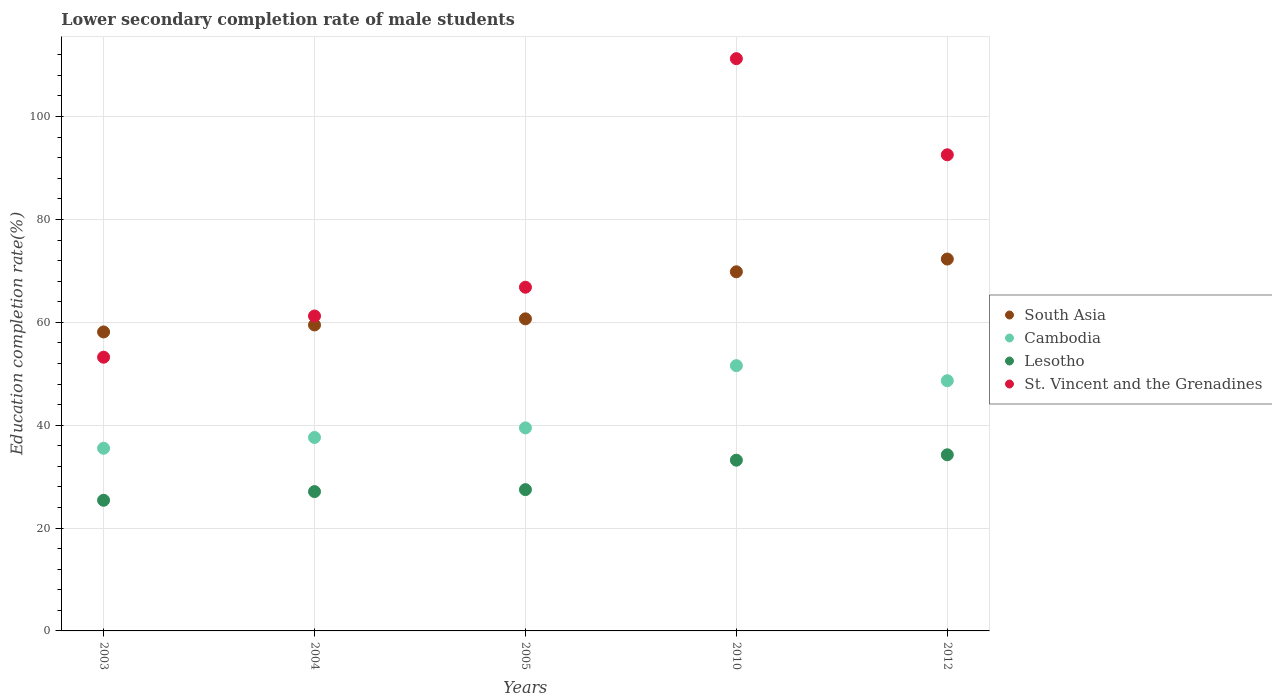How many different coloured dotlines are there?
Offer a terse response. 4. Is the number of dotlines equal to the number of legend labels?
Keep it short and to the point. Yes. What is the lower secondary completion rate of male students in Lesotho in 2012?
Your answer should be very brief. 34.24. Across all years, what is the maximum lower secondary completion rate of male students in St. Vincent and the Grenadines?
Keep it short and to the point. 111.26. Across all years, what is the minimum lower secondary completion rate of male students in Lesotho?
Offer a very short reply. 25.4. In which year was the lower secondary completion rate of male students in South Asia maximum?
Give a very brief answer. 2012. In which year was the lower secondary completion rate of male students in South Asia minimum?
Your answer should be very brief. 2003. What is the total lower secondary completion rate of male students in St. Vincent and the Grenadines in the graph?
Your answer should be very brief. 385.08. What is the difference between the lower secondary completion rate of male students in St. Vincent and the Grenadines in 2004 and that in 2012?
Offer a terse response. -31.34. What is the difference between the lower secondary completion rate of male students in Cambodia in 2005 and the lower secondary completion rate of male students in South Asia in 2012?
Keep it short and to the point. -32.83. What is the average lower secondary completion rate of male students in Cambodia per year?
Your answer should be very brief. 42.56. In the year 2003, what is the difference between the lower secondary completion rate of male students in South Asia and lower secondary completion rate of male students in Lesotho?
Offer a very short reply. 32.73. In how many years, is the lower secondary completion rate of male students in Lesotho greater than 108 %?
Keep it short and to the point. 0. What is the ratio of the lower secondary completion rate of male students in Cambodia in 2003 to that in 2010?
Your answer should be very brief. 0.69. Is the lower secondary completion rate of male students in St. Vincent and the Grenadines in 2010 less than that in 2012?
Provide a succinct answer. No. Is the difference between the lower secondary completion rate of male students in South Asia in 2004 and 2010 greater than the difference between the lower secondary completion rate of male students in Lesotho in 2004 and 2010?
Provide a short and direct response. No. What is the difference between the highest and the second highest lower secondary completion rate of male students in South Asia?
Give a very brief answer. 2.47. What is the difference between the highest and the lowest lower secondary completion rate of male students in Lesotho?
Provide a short and direct response. 8.84. In how many years, is the lower secondary completion rate of male students in St. Vincent and the Grenadines greater than the average lower secondary completion rate of male students in St. Vincent and the Grenadines taken over all years?
Your answer should be compact. 2. Is the sum of the lower secondary completion rate of male students in Lesotho in 2004 and 2005 greater than the maximum lower secondary completion rate of male students in St. Vincent and the Grenadines across all years?
Make the answer very short. No. Is it the case that in every year, the sum of the lower secondary completion rate of male students in South Asia and lower secondary completion rate of male students in St. Vincent and the Grenadines  is greater than the sum of lower secondary completion rate of male students in Cambodia and lower secondary completion rate of male students in Lesotho?
Offer a very short reply. Yes. Is it the case that in every year, the sum of the lower secondary completion rate of male students in Cambodia and lower secondary completion rate of male students in St. Vincent and the Grenadines  is greater than the lower secondary completion rate of male students in South Asia?
Make the answer very short. Yes. Is the lower secondary completion rate of male students in Lesotho strictly greater than the lower secondary completion rate of male students in South Asia over the years?
Give a very brief answer. No. Is the lower secondary completion rate of male students in Cambodia strictly less than the lower secondary completion rate of male students in Lesotho over the years?
Offer a very short reply. No. How many dotlines are there?
Your answer should be very brief. 4. Are the values on the major ticks of Y-axis written in scientific E-notation?
Offer a very short reply. No. Does the graph contain any zero values?
Give a very brief answer. No. What is the title of the graph?
Give a very brief answer. Lower secondary completion rate of male students. Does "Finland" appear as one of the legend labels in the graph?
Your answer should be very brief. No. What is the label or title of the Y-axis?
Offer a terse response. Education completion rate(%). What is the Education completion rate(%) in South Asia in 2003?
Offer a terse response. 58.12. What is the Education completion rate(%) in Cambodia in 2003?
Offer a terse response. 35.51. What is the Education completion rate(%) of Lesotho in 2003?
Keep it short and to the point. 25.4. What is the Education completion rate(%) of St. Vincent and the Grenadines in 2003?
Provide a succinct answer. 53.21. What is the Education completion rate(%) of South Asia in 2004?
Make the answer very short. 59.48. What is the Education completion rate(%) in Cambodia in 2004?
Offer a terse response. 37.61. What is the Education completion rate(%) in Lesotho in 2004?
Offer a very short reply. 27.09. What is the Education completion rate(%) of St. Vincent and the Grenadines in 2004?
Give a very brief answer. 61.23. What is the Education completion rate(%) of South Asia in 2005?
Make the answer very short. 60.67. What is the Education completion rate(%) in Cambodia in 2005?
Provide a short and direct response. 39.47. What is the Education completion rate(%) in Lesotho in 2005?
Your answer should be very brief. 27.47. What is the Education completion rate(%) of St. Vincent and the Grenadines in 2005?
Your answer should be compact. 66.82. What is the Education completion rate(%) in South Asia in 2010?
Make the answer very short. 69.82. What is the Education completion rate(%) of Cambodia in 2010?
Ensure brevity in your answer.  51.57. What is the Education completion rate(%) in Lesotho in 2010?
Your response must be concise. 33.19. What is the Education completion rate(%) of St. Vincent and the Grenadines in 2010?
Your answer should be very brief. 111.26. What is the Education completion rate(%) in South Asia in 2012?
Make the answer very short. 72.3. What is the Education completion rate(%) in Cambodia in 2012?
Provide a short and direct response. 48.64. What is the Education completion rate(%) in Lesotho in 2012?
Your answer should be very brief. 34.24. What is the Education completion rate(%) in St. Vincent and the Grenadines in 2012?
Your answer should be very brief. 92.56. Across all years, what is the maximum Education completion rate(%) in South Asia?
Ensure brevity in your answer.  72.3. Across all years, what is the maximum Education completion rate(%) in Cambodia?
Your answer should be compact. 51.57. Across all years, what is the maximum Education completion rate(%) in Lesotho?
Provide a succinct answer. 34.24. Across all years, what is the maximum Education completion rate(%) of St. Vincent and the Grenadines?
Make the answer very short. 111.26. Across all years, what is the minimum Education completion rate(%) of South Asia?
Keep it short and to the point. 58.12. Across all years, what is the minimum Education completion rate(%) in Cambodia?
Provide a short and direct response. 35.51. Across all years, what is the minimum Education completion rate(%) in Lesotho?
Offer a terse response. 25.4. Across all years, what is the minimum Education completion rate(%) of St. Vincent and the Grenadines?
Your answer should be compact. 53.21. What is the total Education completion rate(%) in South Asia in the graph?
Provide a succinct answer. 320.39. What is the total Education completion rate(%) of Cambodia in the graph?
Your answer should be very brief. 212.8. What is the total Education completion rate(%) of Lesotho in the graph?
Make the answer very short. 147.39. What is the total Education completion rate(%) of St. Vincent and the Grenadines in the graph?
Offer a very short reply. 385.08. What is the difference between the Education completion rate(%) in South Asia in 2003 and that in 2004?
Ensure brevity in your answer.  -1.36. What is the difference between the Education completion rate(%) of Cambodia in 2003 and that in 2004?
Your answer should be compact. -2.1. What is the difference between the Education completion rate(%) of Lesotho in 2003 and that in 2004?
Give a very brief answer. -1.69. What is the difference between the Education completion rate(%) of St. Vincent and the Grenadines in 2003 and that in 2004?
Your answer should be very brief. -8.01. What is the difference between the Education completion rate(%) in South Asia in 2003 and that in 2005?
Keep it short and to the point. -2.55. What is the difference between the Education completion rate(%) of Cambodia in 2003 and that in 2005?
Give a very brief answer. -3.96. What is the difference between the Education completion rate(%) of Lesotho in 2003 and that in 2005?
Your response must be concise. -2.07. What is the difference between the Education completion rate(%) in St. Vincent and the Grenadines in 2003 and that in 2005?
Keep it short and to the point. -13.6. What is the difference between the Education completion rate(%) in South Asia in 2003 and that in 2010?
Your answer should be compact. -11.7. What is the difference between the Education completion rate(%) in Cambodia in 2003 and that in 2010?
Your answer should be very brief. -16.06. What is the difference between the Education completion rate(%) of Lesotho in 2003 and that in 2010?
Offer a terse response. -7.8. What is the difference between the Education completion rate(%) in St. Vincent and the Grenadines in 2003 and that in 2010?
Offer a very short reply. -58.04. What is the difference between the Education completion rate(%) in South Asia in 2003 and that in 2012?
Provide a succinct answer. -14.17. What is the difference between the Education completion rate(%) in Cambodia in 2003 and that in 2012?
Offer a terse response. -13.13. What is the difference between the Education completion rate(%) of Lesotho in 2003 and that in 2012?
Your response must be concise. -8.84. What is the difference between the Education completion rate(%) in St. Vincent and the Grenadines in 2003 and that in 2012?
Make the answer very short. -39.35. What is the difference between the Education completion rate(%) of South Asia in 2004 and that in 2005?
Offer a very short reply. -1.19. What is the difference between the Education completion rate(%) in Cambodia in 2004 and that in 2005?
Give a very brief answer. -1.86. What is the difference between the Education completion rate(%) of Lesotho in 2004 and that in 2005?
Your response must be concise. -0.38. What is the difference between the Education completion rate(%) in St. Vincent and the Grenadines in 2004 and that in 2005?
Provide a short and direct response. -5.59. What is the difference between the Education completion rate(%) in South Asia in 2004 and that in 2010?
Offer a terse response. -10.34. What is the difference between the Education completion rate(%) in Cambodia in 2004 and that in 2010?
Provide a short and direct response. -13.97. What is the difference between the Education completion rate(%) of Lesotho in 2004 and that in 2010?
Make the answer very short. -6.11. What is the difference between the Education completion rate(%) of St. Vincent and the Grenadines in 2004 and that in 2010?
Ensure brevity in your answer.  -50.03. What is the difference between the Education completion rate(%) in South Asia in 2004 and that in 2012?
Provide a succinct answer. -12.81. What is the difference between the Education completion rate(%) of Cambodia in 2004 and that in 2012?
Your response must be concise. -11.04. What is the difference between the Education completion rate(%) of Lesotho in 2004 and that in 2012?
Provide a short and direct response. -7.16. What is the difference between the Education completion rate(%) in St. Vincent and the Grenadines in 2004 and that in 2012?
Offer a very short reply. -31.34. What is the difference between the Education completion rate(%) of South Asia in 2005 and that in 2010?
Your response must be concise. -9.15. What is the difference between the Education completion rate(%) of Cambodia in 2005 and that in 2010?
Keep it short and to the point. -12.1. What is the difference between the Education completion rate(%) of Lesotho in 2005 and that in 2010?
Provide a short and direct response. -5.72. What is the difference between the Education completion rate(%) in St. Vincent and the Grenadines in 2005 and that in 2010?
Make the answer very short. -44.44. What is the difference between the Education completion rate(%) in South Asia in 2005 and that in 2012?
Provide a short and direct response. -11.62. What is the difference between the Education completion rate(%) in Cambodia in 2005 and that in 2012?
Provide a succinct answer. -9.17. What is the difference between the Education completion rate(%) in Lesotho in 2005 and that in 2012?
Provide a succinct answer. -6.77. What is the difference between the Education completion rate(%) of St. Vincent and the Grenadines in 2005 and that in 2012?
Give a very brief answer. -25.75. What is the difference between the Education completion rate(%) of South Asia in 2010 and that in 2012?
Your answer should be very brief. -2.47. What is the difference between the Education completion rate(%) of Cambodia in 2010 and that in 2012?
Make the answer very short. 2.93. What is the difference between the Education completion rate(%) of Lesotho in 2010 and that in 2012?
Provide a succinct answer. -1.05. What is the difference between the Education completion rate(%) of St. Vincent and the Grenadines in 2010 and that in 2012?
Give a very brief answer. 18.69. What is the difference between the Education completion rate(%) of South Asia in 2003 and the Education completion rate(%) of Cambodia in 2004?
Offer a terse response. 20.52. What is the difference between the Education completion rate(%) in South Asia in 2003 and the Education completion rate(%) in Lesotho in 2004?
Your answer should be very brief. 31.04. What is the difference between the Education completion rate(%) of South Asia in 2003 and the Education completion rate(%) of St. Vincent and the Grenadines in 2004?
Offer a very short reply. -3.1. What is the difference between the Education completion rate(%) in Cambodia in 2003 and the Education completion rate(%) in Lesotho in 2004?
Offer a terse response. 8.43. What is the difference between the Education completion rate(%) of Cambodia in 2003 and the Education completion rate(%) of St. Vincent and the Grenadines in 2004?
Keep it short and to the point. -25.72. What is the difference between the Education completion rate(%) of Lesotho in 2003 and the Education completion rate(%) of St. Vincent and the Grenadines in 2004?
Offer a terse response. -35.83. What is the difference between the Education completion rate(%) of South Asia in 2003 and the Education completion rate(%) of Cambodia in 2005?
Offer a very short reply. 18.65. What is the difference between the Education completion rate(%) of South Asia in 2003 and the Education completion rate(%) of Lesotho in 2005?
Provide a short and direct response. 30.65. What is the difference between the Education completion rate(%) in South Asia in 2003 and the Education completion rate(%) in St. Vincent and the Grenadines in 2005?
Offer a terse response. -8.69. What is the difference between the Education completion rate(%) in Cambodia in 2003 and the Education completion rate(%) in Lesotho in 2005?
Keep it short and to the point. 8.04. What is the difference between the Education completion rate(%) of Cambodia in 2003 and the Education completion rate(%) of St. Vincent and the Grenadines in 2005?
Provide a short and direct response. -31.31. What is the difference between the Education completion rate(%) of Lesotho in 2003 and the Education completion rate(%) of St. Vincent and the Grenadines in 2005?
Keep it short and to the point. -41.42. What is the difference between the Education completion rate(%) in South Asia in 2003 and the Education completion rate(%) in Cambodia in 2010?
Make the answer very short. 6.55. What is the difference between the Education completion rate(%) of South Asia in 2003 and the Education completion rate(%) of Lesotho in 2010?
Offer a terse response. 24.93. What is the difference between the Education completion rate(%) of South Asia in 2003 and the Education completion rate(%) of St. Vincent and the Grenadines in 2010?
Make the answer very short. -53.13. What is the difference between the Education completion rate(%) of Cambodia in 2003 and the Education completion rate(%) of Lesotho in 2010?
Offer a terse response. 2.32. What is the difference between the Education completion rate(%) of Cambodia in 2003 and the Education completion rate(%) of St. Vincent and the Grenadines in 2010?
Give a very brief answer. -75.74. What is the difference between the Education completion rate(%) of Lesotho in 2003 and the Education completion rate(%) of St. Vincent and the Grenadines in 2010?
Offer a terse response. -85.86. What is the difference between the Education completion rate(%) of South Asia in 2003 and the Education completion rate(%) of Cambodia in 2012?
Provide a short and direct response. 9.48. What is the difference between the Education completion rate(%) of South Asia in 2003 and the Education completion rate(%) of Lesotho in 2012?
Your response must be concise. 23.88. What is the difference between the Education completion rate(%) of South Asia in 2003 and the Education completion rate(%) of St. Vincent and the Grenadines in 2012?
Ensure brevity in your answer.  -34.44. What is the difference between the Education completion rate(%) of Cambodia in 2003 and the Education completion rate(%) of Lesotho in 2012?
Provide a short and direct response. 1.27. What is the difference between the Education completion rate(%) of Cambodia in 2003 and the Education completion rate(%) of St. Vincent and the Grenadines in 2012?
Provide a succinct answer. -57.05. What is the difference between the Education completion rate(%) of Lesotho in 2003 and the Education completion rate(%) of St. Vincent and the Grenadines in 2012?
Keep it short and to the point. -67.17. What is the difference between the Education completion rate(%) of South Asia in 2004 and the Education completion rate(%) of Cambodia in 2005?
Offer a terse response. 20.01. What is the difference between the Education completion rate(%) in South Asia in 2004 and the Education completion rate(%) in Lesotho in 2005?
Provide a short and direct response. 32.01. What is the difference between the Education completion rate(%) in South Asia in 2004 and the Education completion rate(%) in St. Vincent and the Grenadines in 2005?
Provide a short and direct response. -7.33. What is the difference between the Education completion rate(%) of Cambodia in 2004 and the Education completion rate(%) of Lesotho in 2005?
Provide a succinct answer. 10.14. What is the difference between the Education completion rate(%) of Cambodia in 2004 and the Education completion rate(%) of St. Vincent and the Grenadines in 2005?
Offer a terse response. -29.21. What is the difference between the Education completion rate(%) in Lesotho in 2004 and the Education completion rate(%) in St. Vincent and the Grenadines in 2005?
Give a very brief answer. -39.73. What is the difference between the Education completion rate(%) of South Asia in 2004 and the Education completion rate(%) of Cambodia in 2010?
Offer a very short reply. 7.91. What is the difference between the Education completion rate(%) of South Asia in 2004 and the Education completion rate(%) of Lesotho in 2010?
Ensure brevity in your answer.  26.29. What is the difference between the Education completion rate(%) in South Asia in 2004 and the Education completion rate(%) in St. Vincent and the Grenadines in 2010?
Ensure brevity in your answer.  -51.77. What is the difference between the Education completion rate(%) of Cambodia in 2004 and the Education completion rate(%) of Lesotho in 2010?
Keep it short and to the point. 4.41. What is the difference between the Education completion rate(%) of Cambodia in 2004 and the Education completion rate(%) of St. Vincent and the Grenadines in 2010?
Offer a very short reply. -73.65. What is the difference between the Education completion rate(%) in Lesotho in 2004 and the Education completion rate(%) in St. Vincent and the Grenadines in 2010?
Your answer should be very brief. -84.17. What is the difference between the Education completion rate(%) in South Asia in 2004 and the Education completion rate(%) in Cambodia in 2012?
Make the answer very short. 10.84. What is the difference between the Education completion rate(%) of South Asia in 2004 and the Education completion rate(%) of Lesotho in 2012?
Your answer should be compact. 25.24. What is the difference between the Education completion rate(%) of South Asia in 2004 and the Education completion rate(%) of St. Vincent and the Grenadines in 2012?
Offer a very short reply. -33.08. What is the difference between the Education completion rate(%) in Cambodia in 2004 and the Education completion rate(%) in Lesotho in 2012?
Provide a short and direct response. 3.37. What is the difference between the Education completion rate(%) of Cambodia in 2004 and the Education completion rate(%) of St. Vincent and the Grenadines in 2012?
Provide a short and direct response. -54.96. What is the difference between the Education completion rate(%) of Lesotho in 2004 and the Education completion rate(%) of St. Vincent and the Grenadines in 2012?
Your response must be concise. -65.48. What is the difference between the Education completion rate(%) of South Asia in 2005 and the Education completion rate(%) of Cambodia in 2010?
Ensure brevity in your answer.  9.1. What is the difference between the Education completion rate(%) of South Asia in 2005 and the Education completion rate(%) of Lesotho in 2010?
Provide a short and direct response. 27.48. What is the difference between the Education completion rate(%) in South Asia in 2005 and the Education completion rate(%) in St. Vincent and the Grenadines in 2010?
Give a very brief answer. -50.58. What is the difference between the Education completion rate(%) in Cambodia in 2005 and the Education completion rate(%) in Lesotho in 2010?
Provide a short and direct response. 6.28. What is the difference between the Education completion rate(%) of Cambodia in 2005 and the Education completion rate(%) of St. Vincent and the Grenadines in 2010?
Keep it short and to the point. -71.79. What is the difference between the Education completion rate(%) of Lesotho in 2005 and the Education completion rate(%) of St. Vincent and the Grenadines in 2010?
Provide a succinct answer. -83.79. What is the difference between the Education completion rate(%) of South Asia in 2005 and the Education completion rate(%) of Cambodia in 2012?
Make the answer very short. 12.03. What is the difference between the Education completion rate(%) of South Asia in 2005 and the Education completion rate(%) of Lesotho in 2012?
Offer a terse response. 26.43. What is the difference between the Education completion rate(%) in South Asia in 2005 and the Education completion rate(%) in St. Vincent and the Grenadines in 2012?
Your answer should be compact. -31.89. What is the difference between the Education completion rate(%) of Cambodia in 2005 and the Education completion rate(%) of Lesotho in 2012?
Offer a terse response. 5.23. What is the difference between the Education completion rate(%) in Cambodia in 2005 and the Education completion rate(%) in St. Vincent and the Grenadines in 2012?
Your answer should be very brief. -53.09. What is the difference between the Education completion rate(%) of Lesotho in 2005 and the Education completion rate(%) of St. Vincent and the Grenadines in 2012?
Keep it short and to the point. -65.09. What is the difference between the Education completion rate(%) in South Asia in 2010 and the Education completion rate(%) in Cambodia in 2012?
Your answer should be compact. 21.18. What is the difference between the Education completion rate(%) of South Asia in 2010 and the Education completion rate(%) of Lesotho in 2012?
Your answer should be compact. 35.58. What is the difference between the Education completion rate(%) of South Asia in 2010 and the Education completion rate(%) of St. Vincent and the Grenadines in 2012?
Your response must be concise. -22.74. What is the difference between the Education completion rate(%) in Cambodia in 2010 and the Education completion rate(%) in Lesotho in 2012?
Ensure brevity in your answer.  17.33. What is the difference between the Education completion rate(%) in Cambodia in 2010 and the Education completion rate(%) in St. Vincent and the Grenadines in 2012?
Your answer should be very brief. -40.99. What is the difference between the Education completion rate(%) of Lesotho in 2010 and the Education completion rate(%) of St. Vincent and the Grenadines in 2012?
Provide a succinct answer. -59.37. What is the average Education completion rate(%) of South Asia per year?
Keep it short and to the point. 64.08. What is the average Education completion rate(%) in Cambodia per year?
Ensure brevity in your answer.  42.56. What is the average Education completion rate(%) of Lesotho per year?
Offer a very short reply. 29.48. What is the average Education completion rate(%) in St. Vincent and the Grenadines per year?
Provide a succinct answer. 77.02. In the year 2003, what is the difference between the Education completion rate(%) of South Asia and Education completion rate(%) of Cambodia?
Provide a short and direct response. 22.61. In the year 2003, what is the difference between the Education completion rate(%) in South Asia and Education completion rate(%) in Lesotho?
Ensure brevity in your answer.  32.73. In the year 2003, what is the difference between the Education completion rate(%) of South Asia and Education completion rate(%) of St. Vincent and the Grenadines?
Make the answer very short. 4.91. In the year 2003, what is the difference between the Education completion rate(%) in Cambodia and Education completion rate(%) in Lesotho?
Your response must be concise. 10.11. In the year 2003, what is the difference between the Education completion rate(%) in Cambodia and Education completion rate(%) in St. Vincent and the Grenadines?
Provide a succinct answer. -17.7. In the year 2003, what is the difference between the Education completion rate(%) of Lesotho and Education completion rate(%) of St. Vincent and the Grenadines?
Ensure brevity in your answer.  -27.82. In the year 2004, what is the difference between the Education completion rate(%) of South Asia and Education completion rate(%) of Cambodia?
Your answer should be compact. 21.88. In the year 2004, what is the difference between the Education completion rate(%) in South Asia and Education completion rate(%) in Lesotho?
Your answer should be very brief. 32.4. In the year 2004, what is the difference between the Education completion rate(%) of South Asia and Education completion rate(%) of St. Vincent and the Grenadines?
Make the answer very short. -1.74. In the year 2004, what is the difference between the Education completion rate(%) of Cambodia and Education completion rate(%) of Lesotho?
Keep it short and to the point. 10.52. In the year 2004, what is the difference between the Education completion rate(%) in Cambodia and Education completion rate(%) in St. Vincent and the Grenadines?
Ensure brevity in your answer.  -23.62. In the year 2004, what is the difference between the Education completion rate(%) in Lesotho and Education completion rate(%) in St. Vincent and the Grenadines?
Your answer should be very brief. -34.14. In the year 2005, what is the difference between the Education completion rate(%) of South Asia and Education completion rate(%) of Cambodia?
Provide a succinct answer. 21.2. In the year 2005, what is the difference between the Education completion rate(%) of South Asia and Education completion rate(%) of Lesotho?
Your answer should be very brief. 33.2. In the year 2005, what is the difference between the Education completion rate(%) of South Asia and Education completion rate(%) of St. Vincent and the Grenadines?
Ensure brevity in your answer.  -6.15. In the year 2005, what is the difference between the Education completion rate(%) of Cambodia and Education completion rate(%) of Lesotho?
Your answer should be very brief. 12. In the year 2005, what is the difference between the Education completion rate(%) in Cambodia and Education completion rate(%) in St. Vincent and the Grenadines?
Keep it short and to the point. -27.35. In the year 2005, what is the difference between the Education completion rate(%) of Lesotho and Education completion rate(%) of St. Vincent and the Grenadines?
Your answer should be very brief. -39.35. In the year 2010, what is the difference between the Education completion rate(%) of South Asia and Education completion rate(%) of Cambodia?
Your answer should be compact. 18.25. In the year 2010, what is the difference between the Education completion rate(%) of South Asia and Education completion rate(%) of Lesotho?
Make the answer very short. 36.63. In the year 2010, what is the difference between the Education completion rate(%) in South Asia and Education completion rate(%) in St. Vincent and the Grenadines?
Your answer should be very brief. -41.44. In the year 2010, what is the difference between the Education completion rate(%) in Cambodia and Education completion rate(%) in Lesotho?
Keep it short and to the point. 18.38. In the year 2010, what is the difference between the Education completion rate(%) in Cambodia and Education completion rate(%) in St. Vincent and the Grenadines?
Offer a terse response. -59.68. In the year 2010, what is the difference between the Education completion rate(%) in Lesotho and Education completion rate(%) in St. Vincent and the Grenadines?
Your response must be concise. -78.06. In the year 2012, what is the difference between the Education completion rate(%) in South Asia and Education completion rate(%) in Cambodia?
Your answer should be very brief. 23.65. In the year 2012, what is the difference between the Education completion rate(%) of South Asia and Education completion rate(%) of Lesotho?
Make the answer very short. 38.05. In the year 2012, what is the difference between the Education completion rate(%) in South Asia and Education completion rate(%) in St. Vincent and the Grenadines?
Offer a terse response. -20.27. In the year 2012, what is the difference between the Education completion rate(%) in Cambodia and Education completion rate(%) in Lesotho?
Offer a very short reply. 14.4. In the year 2012, what is the difference between the Education completion rate(%) in Cambodia and Education completion rate(%) in St. Vincent and the Grenadines?
Keep it short and to the point. -43.92. In the year 2012, what is the difference between the Education completion rate(%) in Lesotho and Education completion rate(%) in St. Vincent and the Grenadines?
Keep it short and to the point. -58.32. What is the ratio of the Education completion rate(%) in South Asia in 2003 to that in 2004?
Your answer should be compact. 0.98. What is the ratio of the Education completion rate(%) of Cambodia in 2003 to that in 2004?
Give a very brief answer. 0.94. What is the ratio of the Education completion rate(%) in Lesotho in 2003 to that in 2004?
Provide a short and direct response. 0.94. What is the ratio of the Education completion rate(%) of St. Vincent and the Grenadines in 2003 to that in 2004?
Offer a very short reply. 0.87. What is the ratio of the Education completion rate(%) of South Asia in 2003 to that in 2005?
Keep it short and to the point. 0.96. What is the ratio of the Education completion rate(%) in Cambodia in 2003 to that in 2005?
Keep it short and to the point. 0.9. What is the ratio of the Education completion rate(%) in Lesotho in 2003 to that in 2005?
Keep it short and to the point. 0.92. What is the ratio of the Education completion rate(%) in St. Vincent and the Grenadines in 2003 to that in 2005?
Your answer should be compact. 0.8. What is the ratio of the Education completion rate(%) in South Asia in 2003 to that in 2010?
Your answer should be very brief. 0.83. What is the ratio of the Education completion rate(%) in Cambodia in 2003 to that in 2010?
Your answer should be compact. 0.69. What is the ratio of the Education completion rate(%) in Lesotho in 2003 to that in 2010?
Give a very brief answer. 0.77. What is the ratio of the Education completion rate(%) in St. Vincent and the Grenadines in 2003 to that in 2010?
Ensure brevity in your answer.  0.48. What is the ratio of the Education completion rate(%) of South Asia in 2003 to that in 2012?
Your answer should be very brief. 0.8. What is the ratio of the Education completion rate(%) in Cambodia in 2003 to that in 2012?
Ensure brevity in your answer.  0.73. What is the ratio of the Education completion rate(%) of Lesotho in 2003 to that in 2012?
Offer a very short reply. 0.74. What is the ratio of the Education completion rate(%) of St. Vincent and the Grenadines in 2003 to that in 2012?
Ensure brevity in your answer.  0.57. What is the ratio of the Education completion rate(%) in South Asia in 2004 to that in 2005?
Your answer should be compact. 0.98. What is the ratio of the Education completion rate(%) of Cambodia in 2004 to that in 2005?
Provide a short and direct response. 0.95. What is the ratio of the Education completion rate(%) in St. Vincent and the Grenadines in 2004 to that in 2005?
Provide a short and direct response. 0.92. What is the ratio of the Education completion rate(%) in South Asia in 2004 to that in 2010?
Provide a succinct answer. 0.85. What is the ratio of the Education completion rate(%) in Cambodia in 2004 to that in 2010?
Give a very brief answer. 0.73. What is the ratio of the Education completion rate(%) of Lesotho in 2004 to that in 2010?
Ensure brevity in your answer.  0.82. What is the ratio of the Education completion rate(%) of St. Vincent and the Grenadines in 2004 to that in 2010?
Offer a terse response. 0.55. What is the ratio of the Education completion rate(%) in South Asia in 2004 to that in 2012?
Ensure brevity in your answer.  0.82. What is the ratio of the Education completion rate(%) in Cambodia in 2004 to that in 2012?
Keep it short and to the point. 0.77. What is the ratio of the Education completion rate(%) in Lesotho in 2004 to that in 2012?
Offer a terse response. 0.79. What is the ratio of the Education completion rate(%) of St. Vincent and the Grenadines in 2004 to that in 2012?
Your answer should be very brief. 0.66. What is the ratio of the Education completion rate(%) of South Asia in 2005 to that in 2010?
Ensure brevity in your answer.  0.87. What is the ratio of the Education completion rate(%) of Cambodia in 2005 to that in 2010?
Your response must be concise. 0.77. What is the ratio of the Education completion rate(%) of Lesotho in 2005 to that in 2010?
Make the answer very short. 0.83. What is the ratio of the Education completion rate(%) of St. Vincent and the Grenadines in 2005 to that in 2010?
Your answer should be very brief. 0.6. What is the ratio of the Education completion rate(%) of South Asia in 2005 to that in 2012?
Keep it short and to the point. 0.84. What is the ratio of the Education completion rate(%) in Cambodia in 2005 to that in 2012?
Provide a short and direct response. 0.81. What is the ratio of the Education completion rate(%) of Lesotho in 2005 to that in 2012?
Give a very brief answer. 0.8. What is the ratio of the Education completion rate(%) in St. Vincent and the Grenadines in 2005 to that in 2012?
Ensure brevity in your answer.  0.72. What is the ratio of the Education completion rate(%) of South Asia in 2010 to that in 2012?
Your answer should be compact. 0.97. What is the ratio of the Education completion rate(%) of Cambodia in 2010 to that in 2012?
Offer a terse response. 1.06. What is the ratio of the Education completion rate(%) of Lesotho in 2010 to that in 2012?
Ensure brevity in your answer.  0.97. What is the ratio of the Education completion rate(%) in St. Vincent and the Grenadines in 2010 to that in 2012?
Make the answer very short. 1.2. What is the difference between the highest and the second highest Education completion rate(%) in South Asia?
Provide a short and direct response. 2.47. What is the difference between the highest and the second highest Education completion rate(%) in Cambodia?
Offer a terse response. 2.93. What is the difference between the highest and the second highest Education completion rate(%) in Lesotho?
Offer a terse response. 1.05. What is the difference between the highest and the second highest Education completion rate(%) in St. Vincent and the Grenadines?
Offer a very short reply. 18.69. What is the difference between the highest and the lowest Education completion rate(%) of South Asia?
Offer a terse response. 14.17. What is the difference between the highest and the lowest Education completion rate(%) of Cambodia?
Provide a short and direct response. 16.06. What is the difference between the highest and the lowest Education completion rate(%) in Lesotho?
Ensure brevity in your answer.  8.84. What is the difference between the highest and the lowest Education completion rate(%) of St. Vincent and the Grenadines?
Your response must be concise. 58.04. 